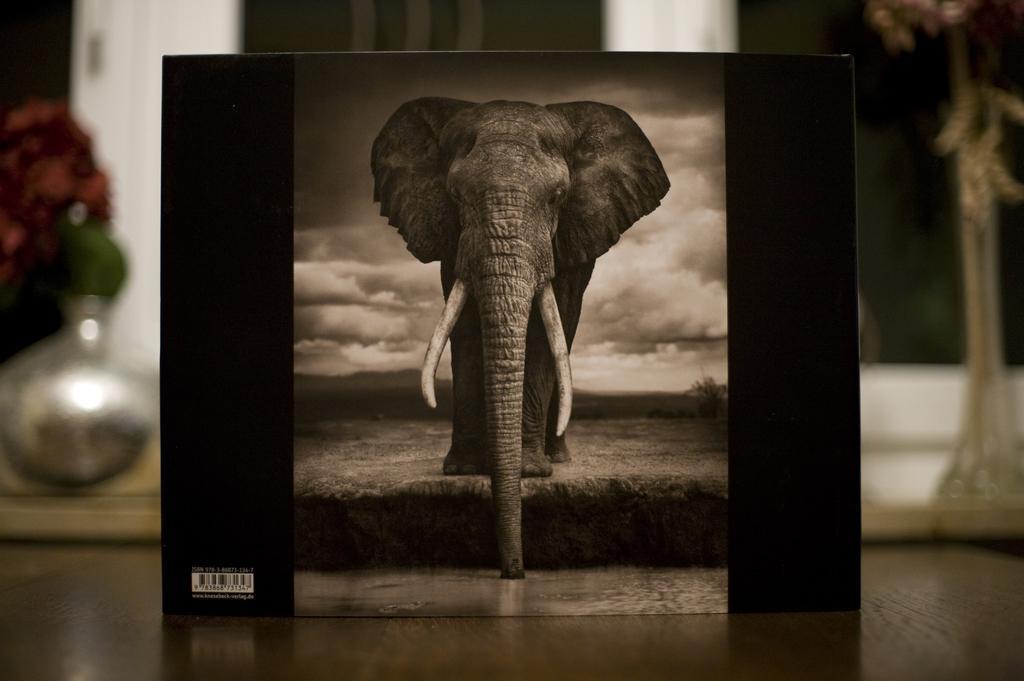Can you describe this image briefly? In this picture I can see there is a elephant drinking water from the lake, in front of it. It is standing on the ground and this is a photo frame and there is a bar code on the frame. The frame is placed on a table and there are flower vases in the backdrop and there is a wall. 